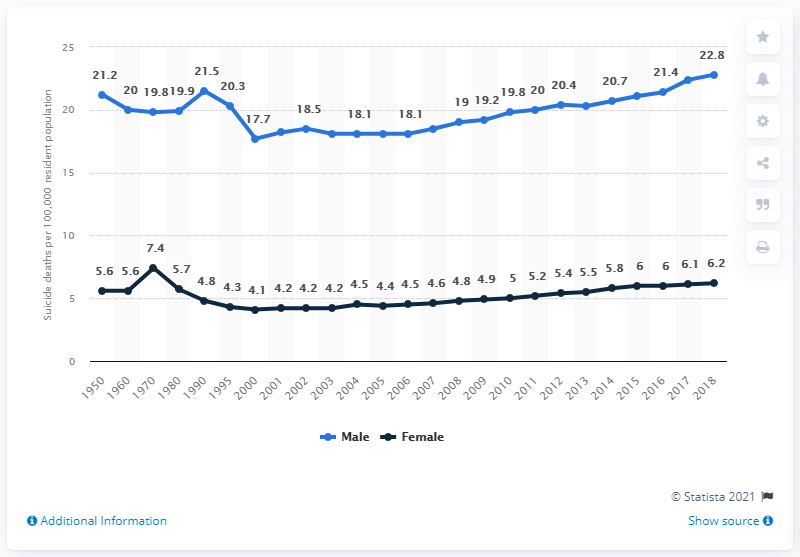Point out several critical features in this image. There were 22,800 male suicides in the United States in 2018. 